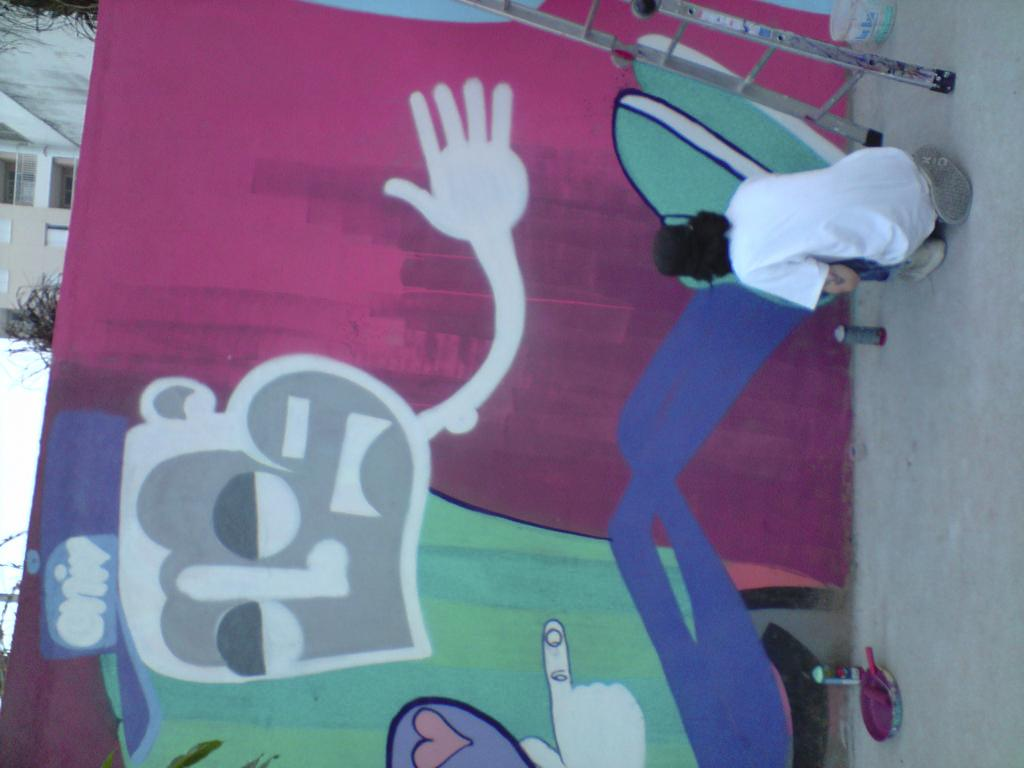How is the image oriented? The image is tilted. What is the person in the image doing? The person is sitting and painting a wall. What is the person using to reach the higher parts of the wall? There is a ladder beside the person. What is the plot of the story unfolding in the image? There is no story or plot depicted in the image; it simply shows a person sitting and painting a wall with a ladder beside them. What is the relation between the person and the wall in the image? The person is painting the wall, which implies a working relationship between the person and the wall. 